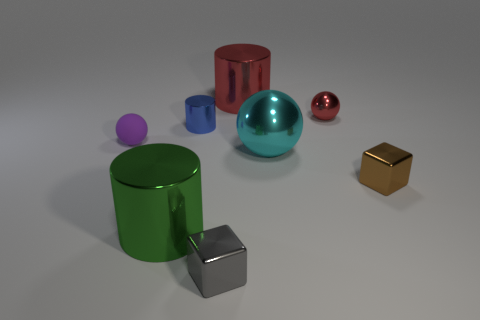Are there any large metal cylinders of the same color as the tiny metal ball? There is one large metal cylinder that has the same color as the small metal ball - they both have a shiny red hue. 